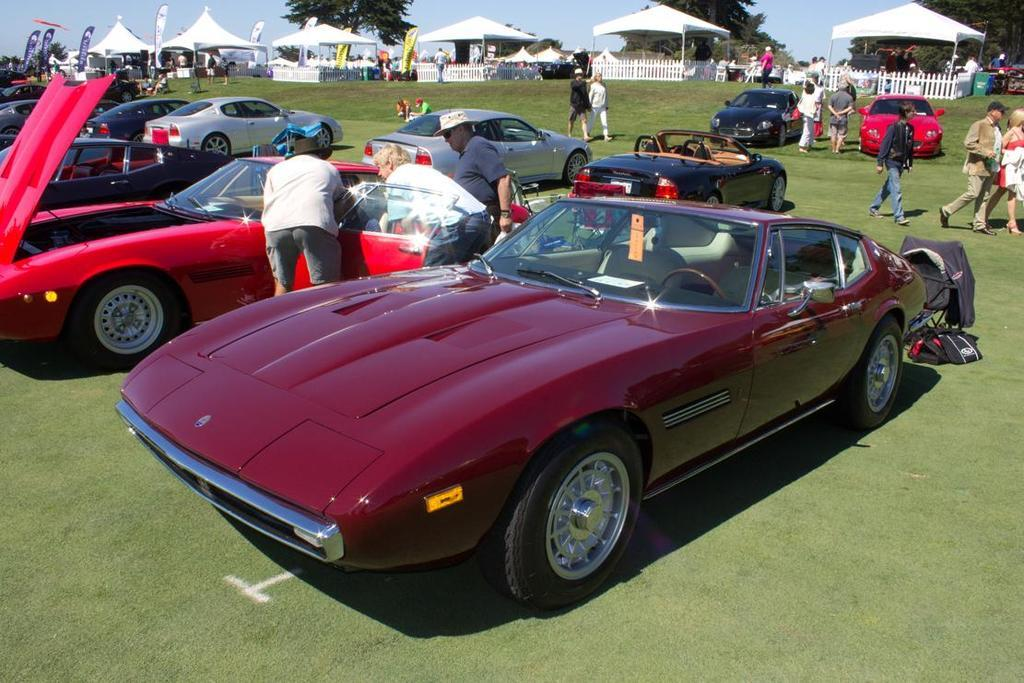What types of objects are present in the image? There are vehicles, tents, and a fence in the image. Can you describe the people in the image? There is a group of people on the ground in the image. What type of terrain is visible in the image? Grass is visible in the image. What else can be seen in the background of the image? Trees and the sky are visible in the image. What type of yam is being used as a volleyball in the image? There is no yam or volleyball present in the image. Where is the sofa located in the image? There is no sofa present in the image. 